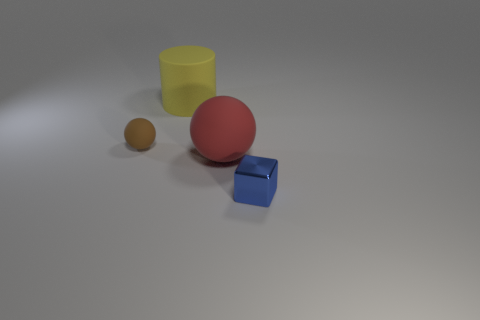Is the number of large red matte objects that are to the left of the brown matte object the same as the number of big yellow objects that are behind the small shiny cube?
Provide a succinct answer. No. What number of tiny metal cubes are on the right side of the brown ball?
Your answer should be compact. 1. How many objects are blue shiny blocks or rubber balls?
Give a very brief answer. 3. What number of red spheres have the same size as the blue metallic cube?
Offer a very short reply. 0. What shape is the big object behind the matte thing in front of the small brown rubber object?
Make the answer very short. Cylinder. Is the number of red matte spheres less than the number of big things?
Offer a terse response. Yes. There is a tiny thing that is left of the shiny cube; what color is it?
Offer a very short reply. Brown. What is the material of the object that is both on the left side of the big red matte object and to the right of the brown matte thing?
Your response must be concise. Rubber. There is another large object that is the same material as the big yellow object; what shape is it?
Your answer should be very brief. Sphere. There is a thing that is in front of the red matte ball; what number of small metallic cubes are on the right side of it?
Provide a succinct answer. 0. 